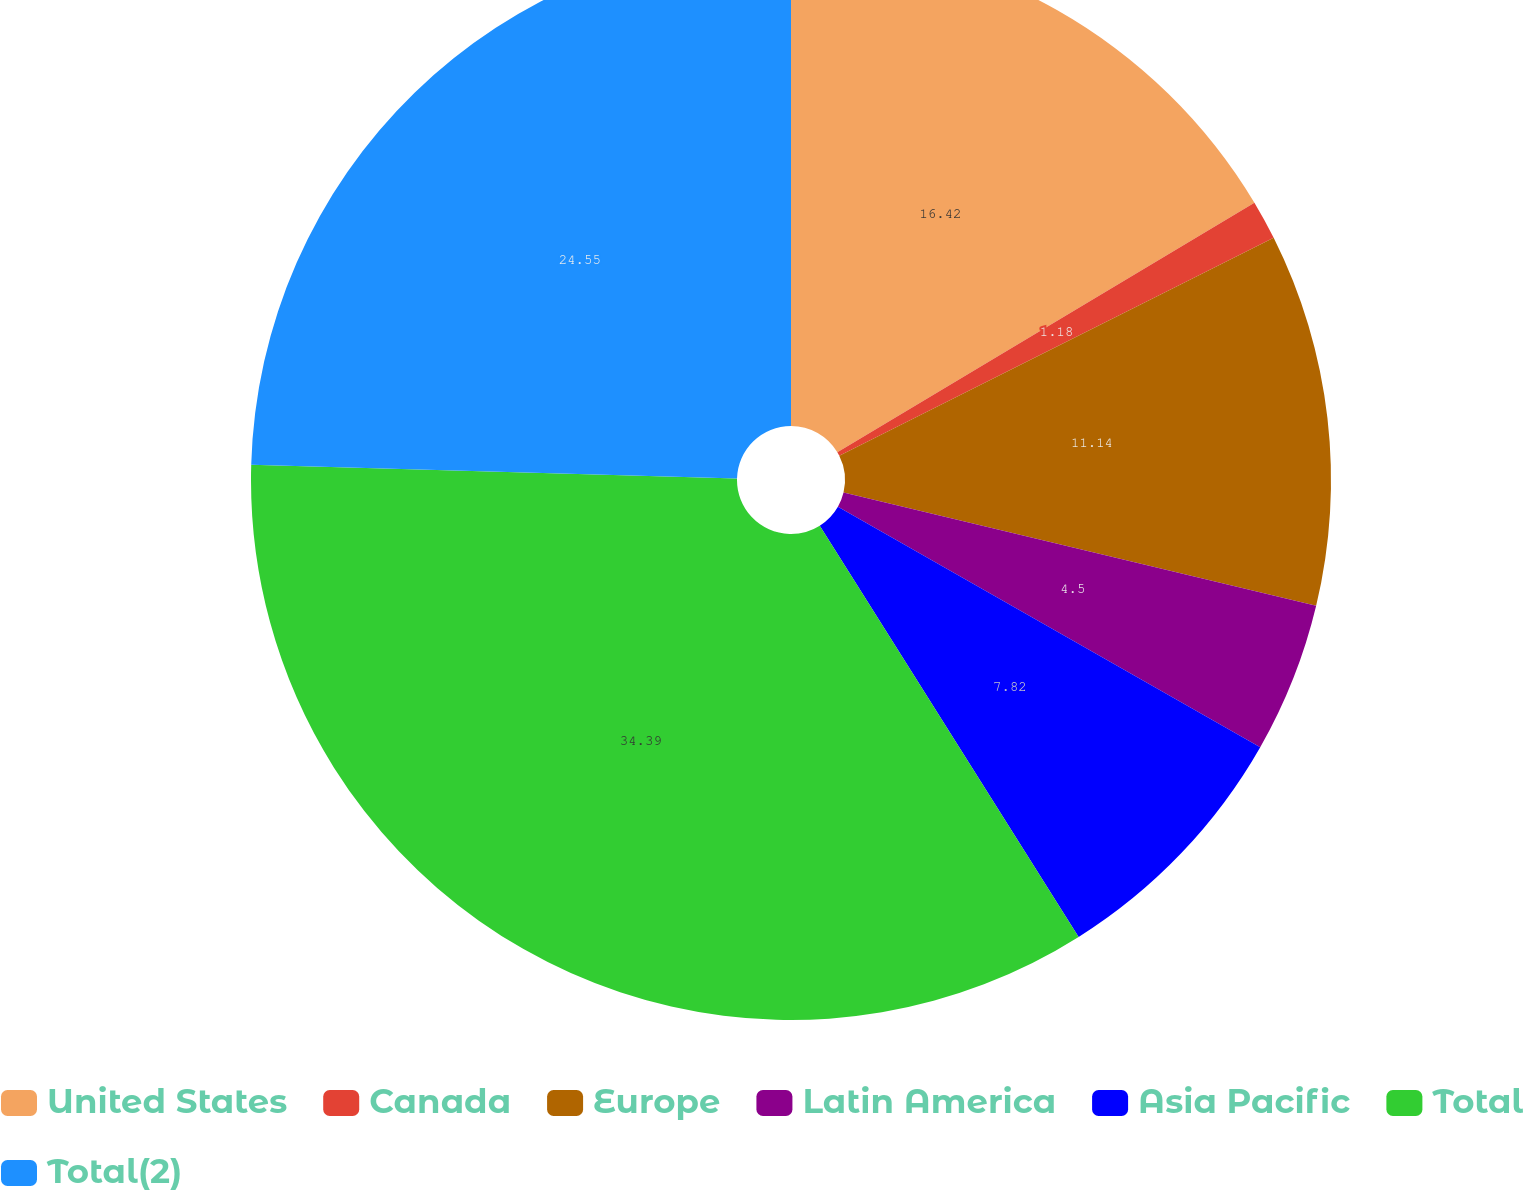Convert chart to OTSL. <chart><loc_0><loc_0><loc_500><loc_500><pie_chart><fcel>United States<fcel>Canada<fcel>Europe<fcel>Latin America<fcel>Asia Pacific<fcel>Total<fcel>Total(2)<nl><fcel>16.42%<fcel>1.18%<fcel>11.14%<fcel>4.5%<fcel>7.82%<fcel>34.39%<fcel>24.55%<nl></chart> 